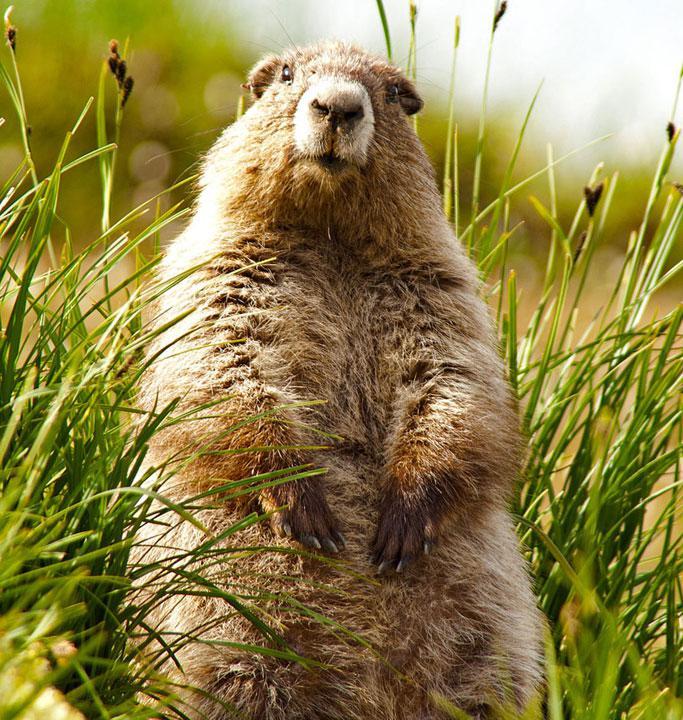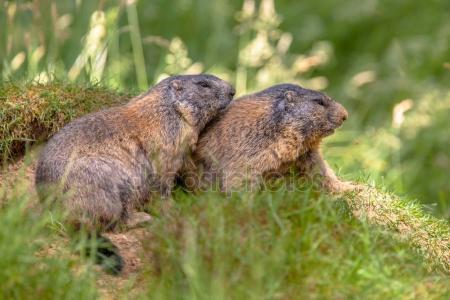The first image is the image on the left, the second image is the image on the right. For the images displayed, is the sentence "An image contains one marmot, which stands upright in green grass with its body turned to the camera." factually correct? Answer yes or no. Yes. The first image is the image on the left, the second image is the image on the right. For the images displayed, is the sentence "The left image contains exactly one rodent standing on grass." factually correct? Answer yes or no. Yes. 